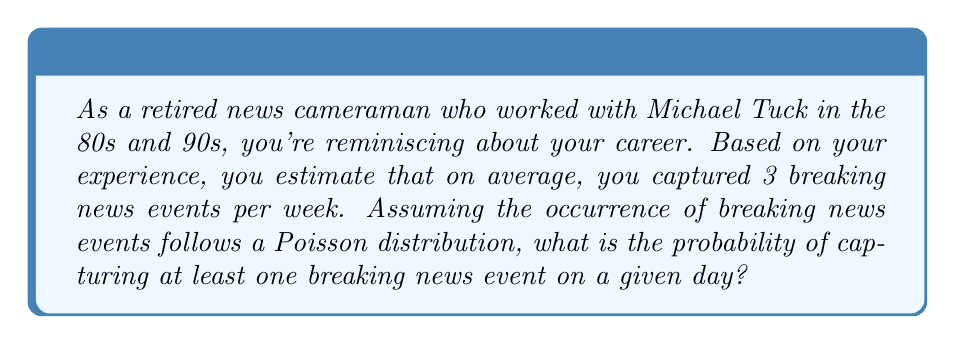Help me with this question. Let's approach this step-by-step:

1) First, we need to calculate the average number of breaking news events per day:
   $\lambda_{day} = \frac{3 \text{ events per week}}{7 \text{ days}} = \frac{3}{7} \approx 0.4286$ events per day

2) The Poisson distribution gives the probability of a specific number of events occurring in a fixed interval of time or space if these events occur with a known average rate and independently of the time since the last event.

3) The probability of exactly $k$ events in a Poisson distribution is given by:

   $$P(X = k) = \frac{e^{-\lambda}\lambda^k}{k!}$$

   where $\lambda$ is the average number of events per interval.

4) We want the probability of at least one event, which is the same as 1 minus the probability of zero events:

   $$P(X \geq 1) = 1 - P(X = 0)$$

5) Calculating $P(X = 0)$:

   $$P(X = 0) = \frac{e^{-0.4286}(0.4286)^0}{0!} = e^{-0.4286} \approx 0.6515$$

6) Therefore, the probability of at least one event is:

   $$P(X \geq 1) = 1 - 0.6515 \approx 0.3485$$
Answer: $0.3485$ or $34.85\%$ 